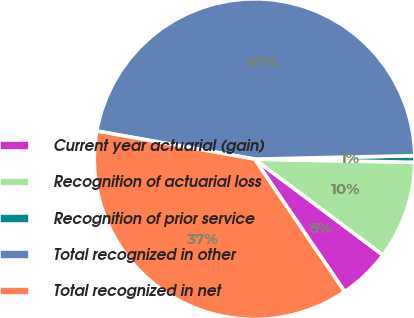<chart> <loc_0><loc_0><loc_500><loc_500><pie_chart><fcel>Current year actuarial (gain)<fcel>Recognition of actuarial loss<fcel>Recognition of prior service<fcel>Total recognized in other<fcel>Total recognized in net<nl><fcel>5.28%<fcel>9.9%<fcel>0.66%<fcel>46.85%<fcel>37.3%<nl></chart> 